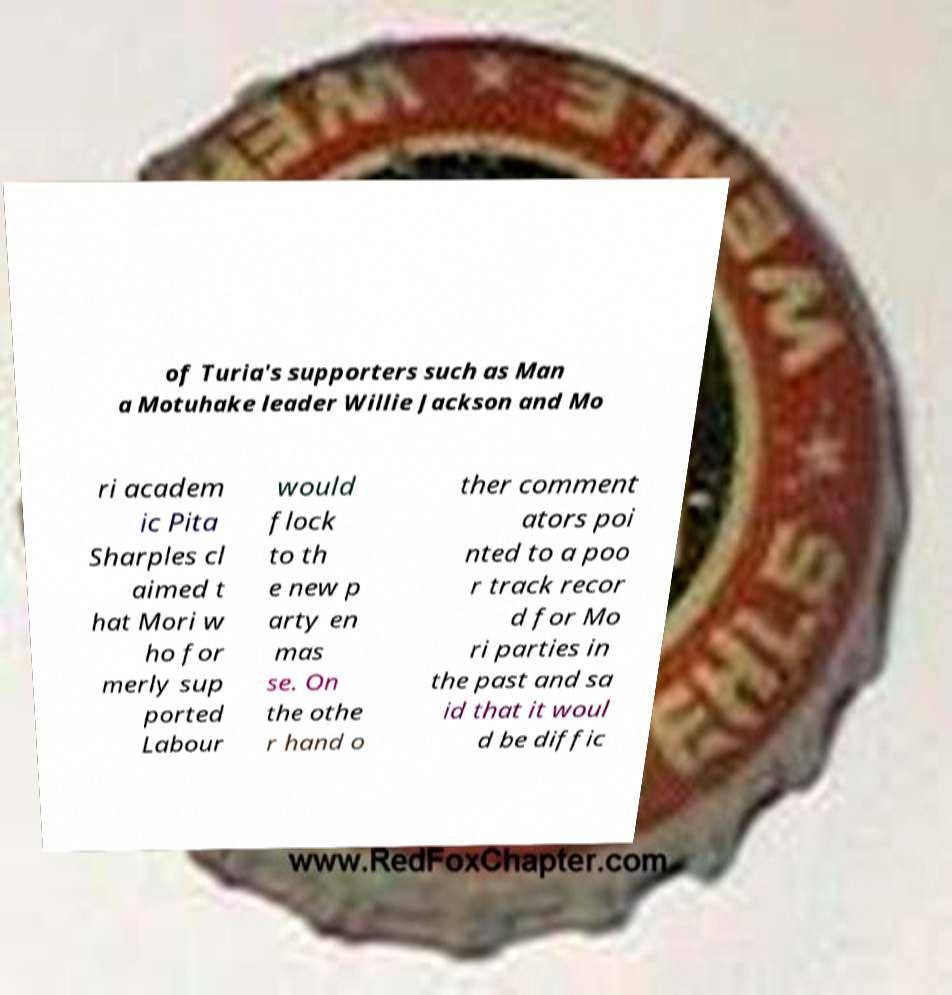There's text embedded in this image that I need extracted. Can you transcribe it verbatim? of Turia's supporters such as Man a Motuhake leader Willie Jackson and Mo ri academ ic Pita Sharples cl aimed t hat Mori w ho for merly sup ported Labour would flock to th e new p arty en mas se. On the othe r hand o ther comment ators poi nted to a poo r track recor d for Mo ri parties in the past and sa id that it woul d be diffic 